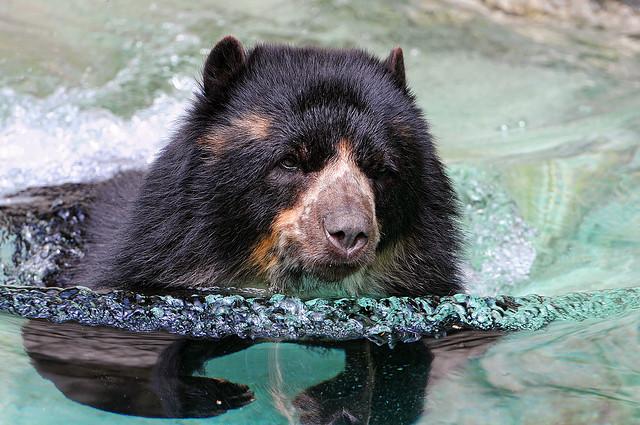What color is the bears snout?
Give a very brief answer. Brown. Is the water clear?
Be succinct. Yes. Is the animal swimming in the sea?
Short answer required. No. Is the bear taking a bath?
Short answer required. No. 